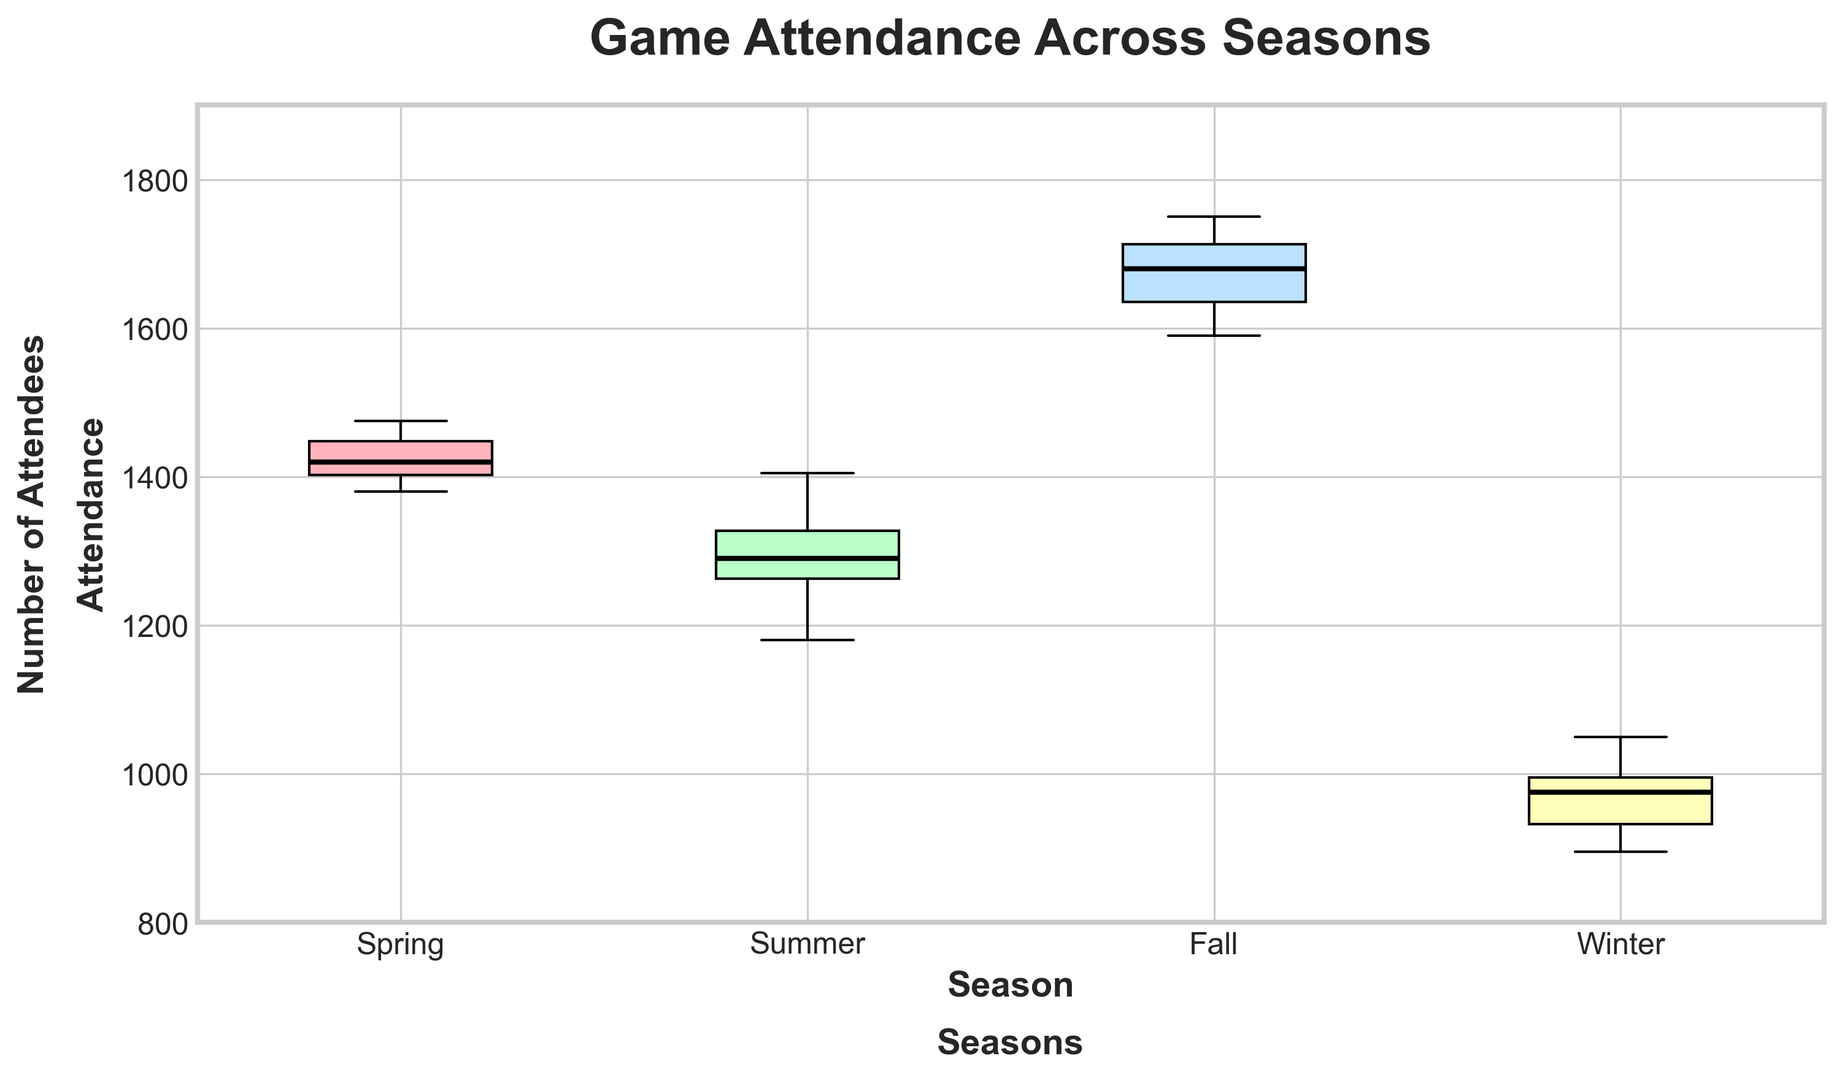What's the median attendance for Spring games? The median attendance is the middle value when the numbers are listed in order. Sorting Spring attendances: 1180, 1250, 1275, 1290, 1320, 1335, 1405. The median is the fourth value, which is 1290.
Answer: 1290 Which season has the highest median attendance? The median attendance for each season should be found and compared. For Spring: 1290; Summer: 1680; Fall: 1420; Winter: 975. Summer has the highest median attendance.
Answer: Summer Is the range of attendance wider in Summer or Winter? Range is calculated by subtracting the minimum value from the maximum value for each season. For Summer, range = 1750 - 1590 = 160. For Winter, range = 1050 - 895 = 155. Summer's range is wider.
Answer: Summer What is the interquartile range (IQR) for Fall games? IQR is the difference between the third quartile (Q3) and the first quartile (Q1). Ordered fall data: 1380, 1395, 1410, 1420, 1435, 1460, 1475. Q1 (25th percentile) is 1395, and Q3 (75th percentile) is 1460. IQR = 1460 - 1395 = 65.
Answer: 65 Which season has the lowest lower quartile (Q1), and what is that value? Lower quartile (Q1) is the 25th percentile value within an ordered dataset. For Spring: Q1 = 1250; Summer: Q1 = 1620; Fall: Q1 = 1395; Winter: Q1 = 925. Winter has the lowest Q1, which is 925.
Answer: Winter, 925 Are there any outliers in the Fall attendance data? Outliers commonly fall outside 1.5*IQR from Q1 and Q3. For Fall, Q1 = 1395, Q3 = 1460, IQR = 65. Lower bound = 1395 - 1.5*65 = 1297.5, Upper bound = 1460 + 1.5*65 = 1557.5. All Fall data points are within these bounds, so there are no outliers.
Answer: No Between Spring and Fall, which has a wider spread of attendance data? Spread can be evaluated by range and IQR. For Spring: Range = 1405 - 1180 = 225, IQR = 1335 - 1250 = 85. For Fall: Range = 1475 - 1380 = 95, IQR = 1460 - 1395 = 65. Spring has a wider spread.
Answer: Spring Which season's attendance has the highest maximum value? The highest attendance from each season is examined: Spring's maximum is 1405, Summer's maximum is 1750, Fall's maximum is 1475, Winter's maximum is 1050. The highest maximum attendance is in Summer (1750).
Answer: Summer 